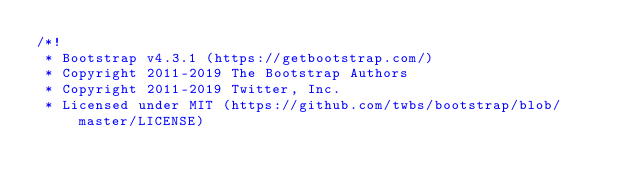Convert code to text. <code><loc_0><loc_0><loc_500><loc_500><_CSS_>/*!
 * Bootstrap v4.3.1 (https://getbootstrap.com/)
 * Copyright 2011-2019 The Bootstrap Authors
 * Copyright 2011-2019 Twitter, Inc.
 * Licensed under MIT (https://github.com/twbs/bootstrap/blob/master/LICENSE)</code> 